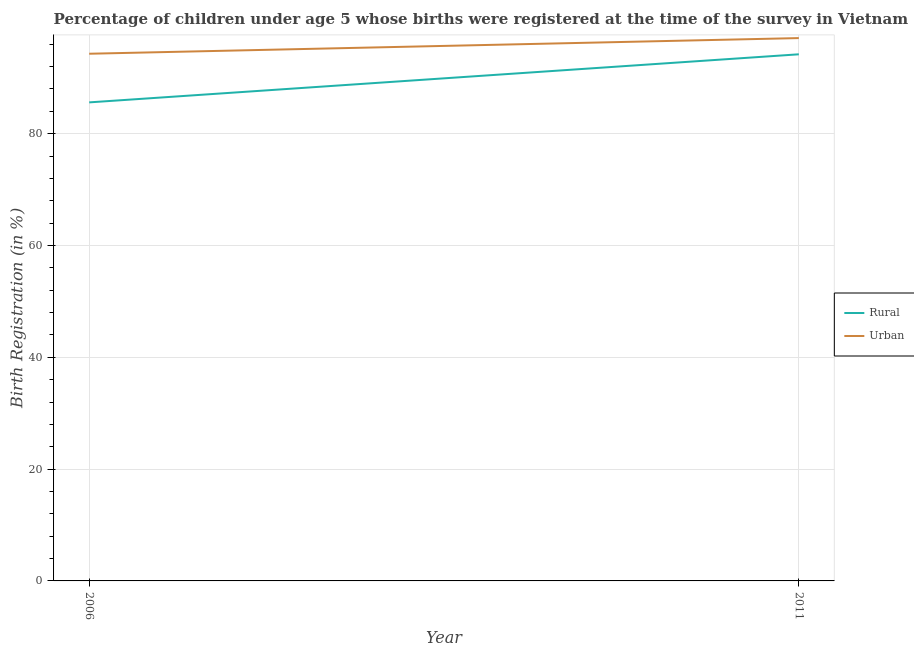How many different coloured lines are there?
Provide a short and direct response. 2. Does the line corresponding to rural birth registration intersect with the line corresponding to urban birth registration?
Keep it short and to the point. No. What is the rural birth registration in 2006?
Make the answer very short. 85.6. Across all years, what is the maximum rural birth registration?
Ensure brevity in your answer.  94.2. Across all years, what is the minimum rural birth registration?
Your answer should be compact. 85.6. In which year was the rural birth registration maximum?
Ensure brevity in your answer.  2011. What is the total urban birth registration in the graph?
Make the answer very short. 191.4. What is the difference between the urban birth registration in 2006 and that in 2011?
Keep it short and to the point. -2.8. What is the difference between the urban birth registration in 2006 and the rural birth registration in 2011?
Your answer should be compact. 0.1. What is the average urban birth registration per year?
Offer a very short reply. 95.7. In the year 2006, what is the difference between the urban birth registration and rural birth registration?
Make the answer very short. 8.7. What is the ratio of the urban birth registration in 2006 to that in 2011?
Your answer should be compact. 0.97. Is the urban birth registration in 2006 less than that in 2011?
Offer a terse response. Yes. In how many years, is the rural birth registration greater than the average rural birth registration taken over all years?
Provide a succinct answer. 1. Does the urban birth registration monotonically increase over the years?
Give a very brief answer. Yes. Is the rural birth registration strictly less than the urban birth registration over the years?
Make the answer very short. Yes. How many lines are there?
Provide a succinct answer. 2. How many years are there in the graph?
Provide a short and direct response. 2. Are the values on the major ticks of Y-axis written in scientific E-notation?
Your answer should be very brief. No. Does the graph contain any zero values?
Ensure brevity in your answer.  No. Does the graph contain grids?
Give a very brief answer. Yes. Where does the legend appear in the graph?
Offer a terse response. Center right. What is the title of the graph?
Offer a very short reply. Percentage of children under age 5 whose births were registered at the time of the survey in Vietnam. What is the label or title of the X-axis?
Offer a very short reply. Year. What is the label or title of the Y-axis?
Your answer should be compact. Birth Registration (in %). What is the Birth Registration (in %) in Rural in 2006?
Offer a terse response. 85.6. What is the Birth Registration (in %) in Urban in 2006?
Your response must be concise. 94.3. What is the Birth Registration (in %) of Rural in 2011?
Offer a very short reply. 94.2. What is the Birth Registration (in %) of Urban in 2011?
Make the answer very short. 97.1. Across all years, what is the maximum Birth Registration (in %) of Rural?
Provide a short and direct response. 94.2. Across all years, what is the maximum Birth Registration (in %) of Urban?
Ensure brevity in your answer.  97.1. Across all years, what is the minimum Birth Registration (in %) of Rural?
Offer a very short reply. 85.6. Across all years, what is the minimum Birth Registration (in %) of Urban?
Give a very brief answer. 94.3. What is the total Birth Registration (in %) of Rural in the graph?
Make the answer very short. 179.8. What is the total Birth Registration (in %) of Urban in the graph?
Give a very brief answer. 191.4. What is the difference between the Birth Registration (in %) of Rural in 2006 and that in 2011?
Provide a succinct answer. -8.6. What is the difference between the Birth Registration (in %) of Rural in 2006 and the Birth Registration (in %) of Urban in 2011?
Your response must be concise. -11.5. What is the average Birth Registration (in %) in Rural per year?
Offer a very short reply. 89.9. What is the average Birth Registration (in %) in Urban per year?
Ensure brevity in your answer.  95.7. In the year 2011, what is the difference between the Birth Registration (in %) of Rural and Birth Registration (in %) of Urban?
Offer a very short reply. -2.9. What is the ratio of the Birth Registration (in %) in Rural in 2006 to that in 2011?
Your answer should be very brief. 0.91. What is the ratio of the Birth Registration (in %) of Urban in 2006 to that in 2011?
Give a very brief answer. 0.97. What is the difference between the highest and the second highest Birth Registration (in %) of Rural?
Offer a terse response. 8.6. What is the difference between the highest and the lowest Birth Registration (in %) of Urban?
Offer a terse response. 2.8. 